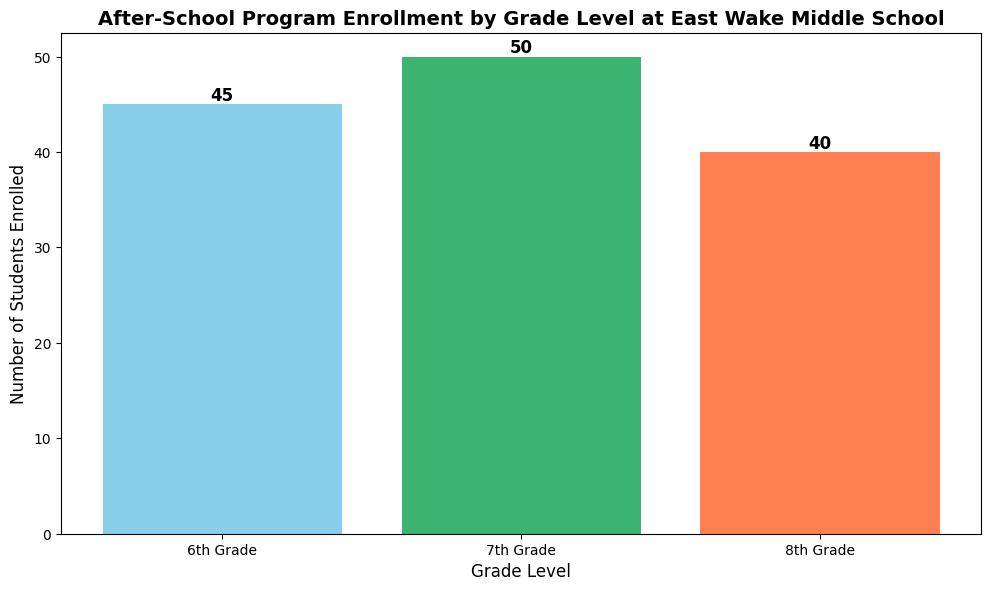What's the total enrollment for the after-school program across all grade levels? Sum the enrollments for 6th Grade (45), 7th Grade (50), and 8th Grade (40). The total is 45 + 50 + 40 = 135.
Answer: 135 Which grade level has the highest enrollment in the after-school program? Compare the enrollment numbers of 6th Grade (45), 7th Grade (50), and 8th Grade (40). The 7th Grade has the highest enrollment at 50.
Answer: 7th Grade By how much does the 7th Grade enrollment exceed the 8th Grade enrollment? Subtract the 8th Grade enrollment (40) from the 7th Grade enrollment (50). 50 - 40 = 10. The 7th Grade enrollment exceeds the 8th Grade enrollment by 10 students.
Answer: 10 What is the average enrollment per grade for the after-school program? Sum the enrollments for all grades and divide by the number of grades. The total enrollment is 135, and there are 3 grades. 135 / 3 = 45. The average enrollment per grade is 45.
Answer: 45 Which grade has the shortest bar in the bar chart? Visually inspect the heights of the bars representing each grade. The 8th Grade, with an enrollment of 40, has the shortest bar.
Answer: 8th Grade What proportion of the total enrollment is the 6th Grade's enrollment? Calculate the ratio of the 6th Grade enrollment (45) to the total enrollment (135). The proportion is 45 / 135 = 1/3 or approximately 33.33%.
Answer: 33.33% What is the difference in enrollment between the grade with the highest enrollment and the grade with the lowest enrollment? Determine the highest (7th Grade, 50) and the lowest (8th Grade, 40) enrollments, then find the difference. 50 - 40 = 10.
Answer: 10 If we add 10 more students to each grade level, what will the new total enrollment be? Add 10 to each current enrollment (6th Grade: 45+10=55, 7th Grade: 50+10=60, 8th Grade: 40+10=50) and then sum the new enrollments. 55 + 60 + 50 = 165.
Answer: 165 